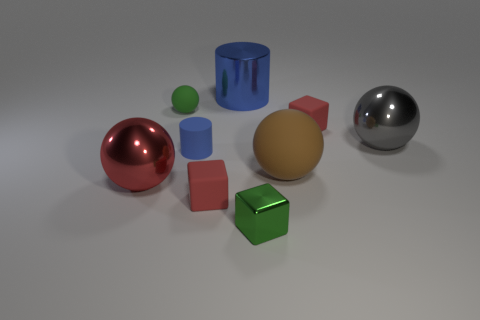Subtract all blue cylinders. How many were subtracted if there are1blue cylinders left? 1 Subtract all red matte blocks. How many blocks are left? 1 Subtract 1 spheres. How many spheres are left? 3 Add 1 small cubes. How many objects exist? 10 Subtract all yellow balls. Subtract all yellow cubes. How many balls are left? 4 Subtract all balls. How many objects are left? 5 Subtract 1 blue cylinders. How many objects are left? 8 Subtract all small matte cubes. Subtract all large metallic things. How many objects are left? 4 Add 3 tiny green rubber things. How many tiny green rubber things are left? 4 Add 7 blue matte cylinders. How many blue matte cylinders exist? 8 